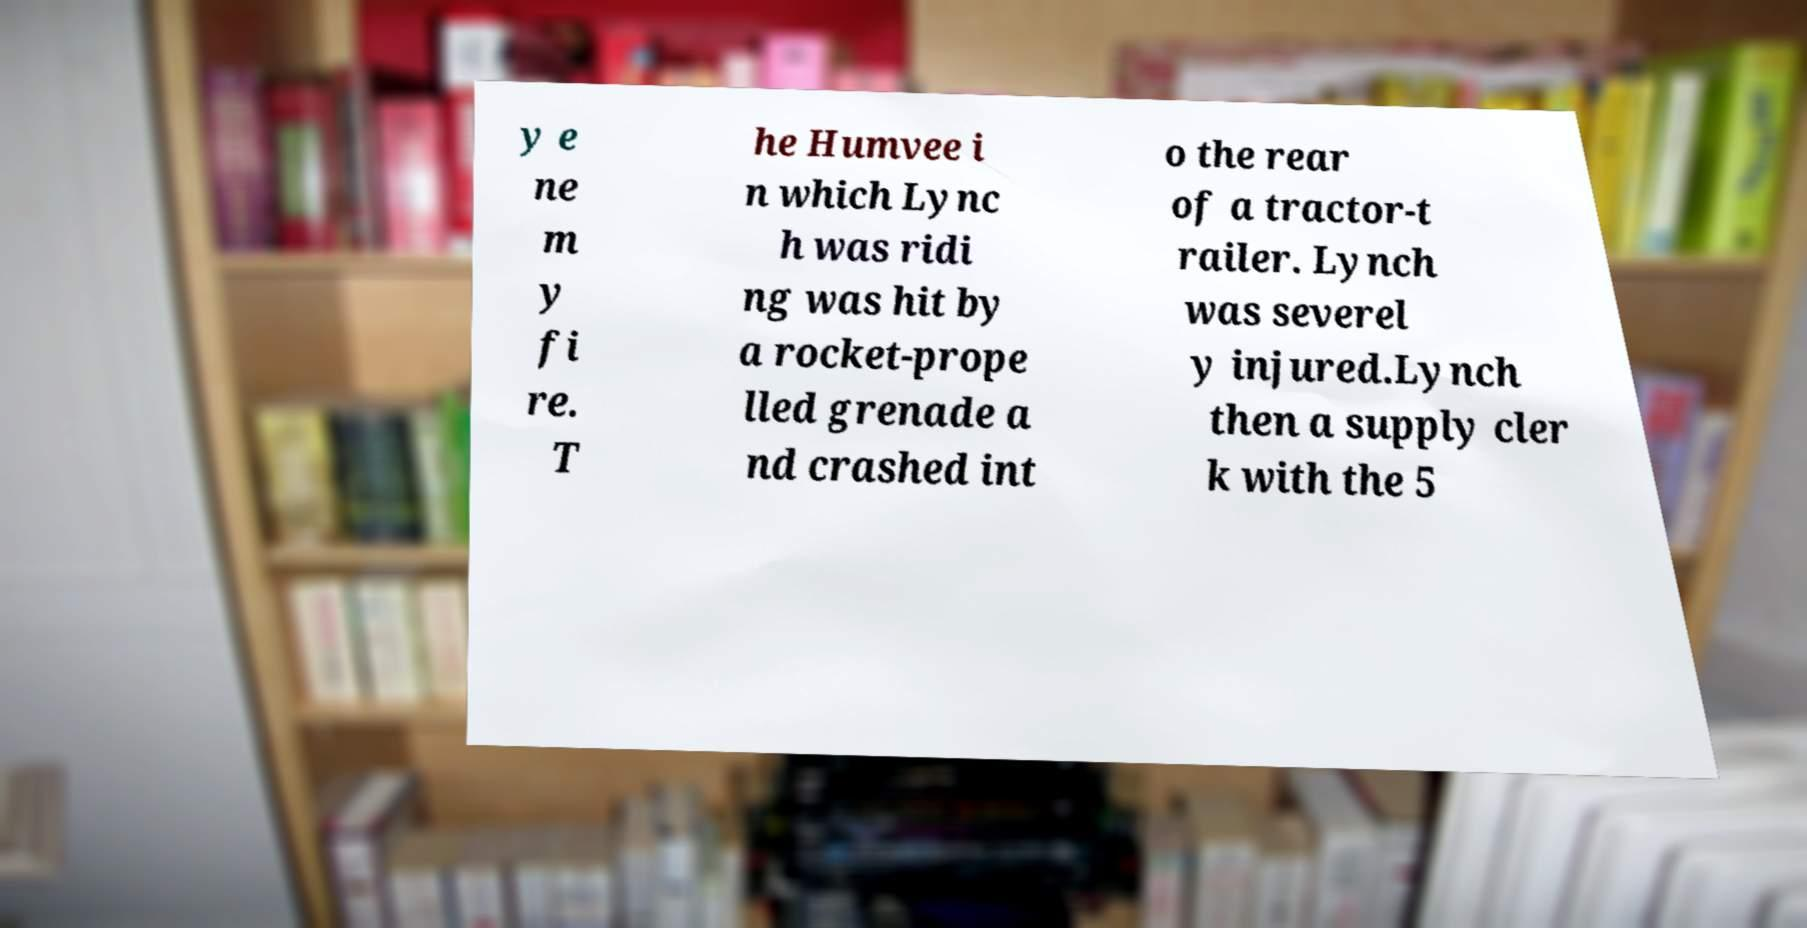There's text embedded in this image that I need extracted. Can you transcribe it verbatim? y e ne m y fi re. T he Humvee i n which Lync h was ridi ng was hit by a rocket-prope lled grenade a nd crashed int o the rear of a tractor-t railer. Lynch was severel y injured.Lynch then a supply cler k with the 5 